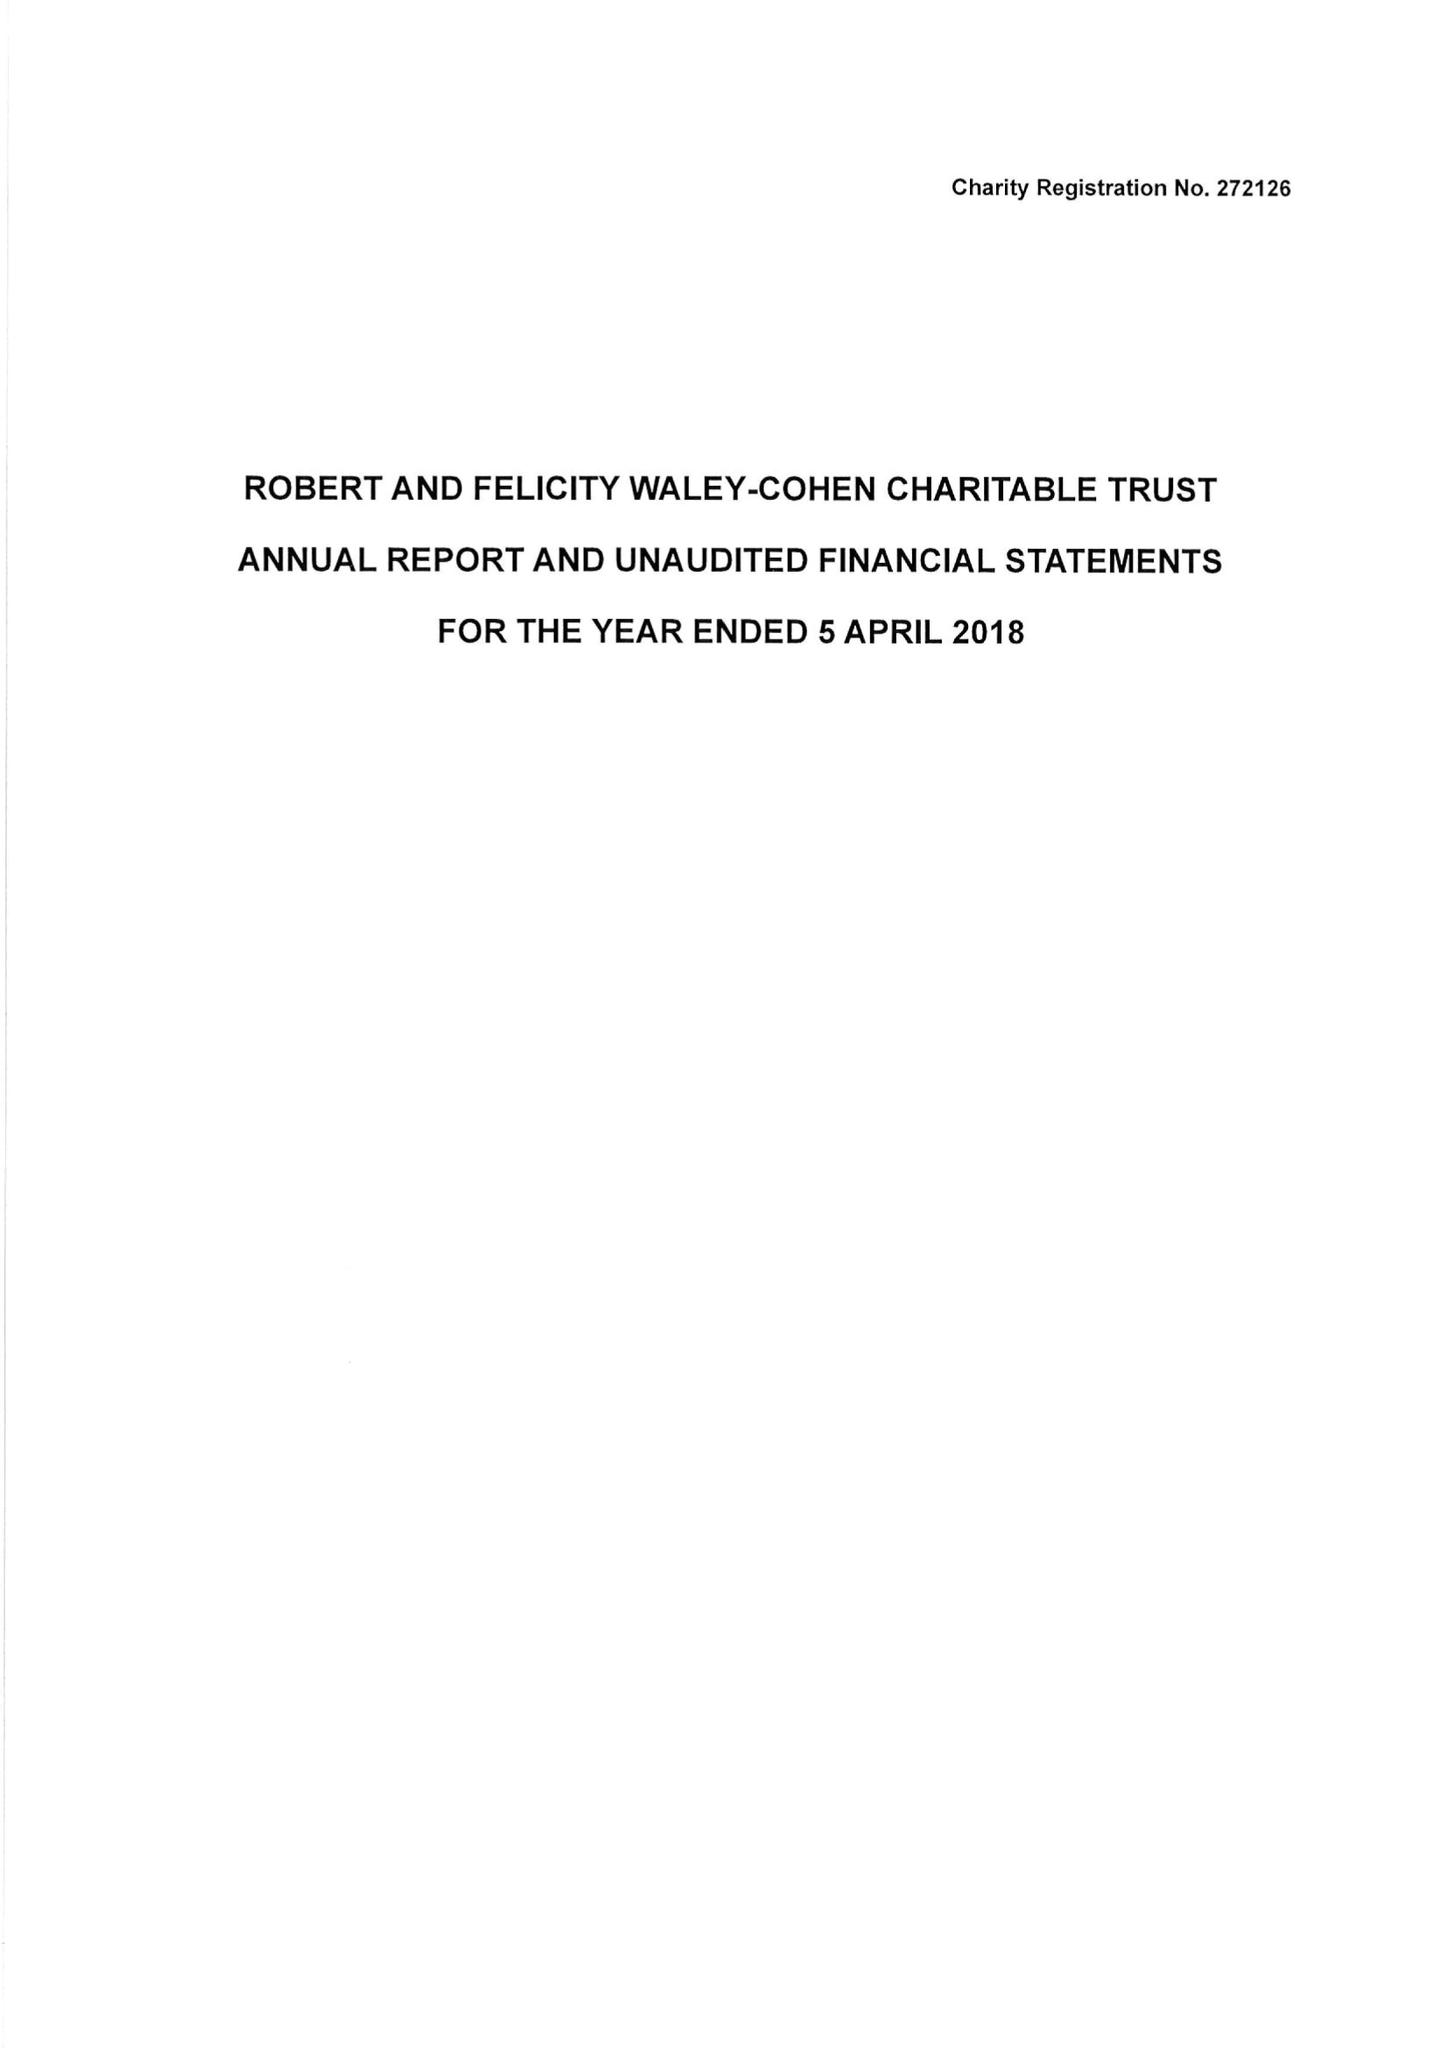What is the value for the address__post_town?
Answer the question using a single word or phrase. LONDON 